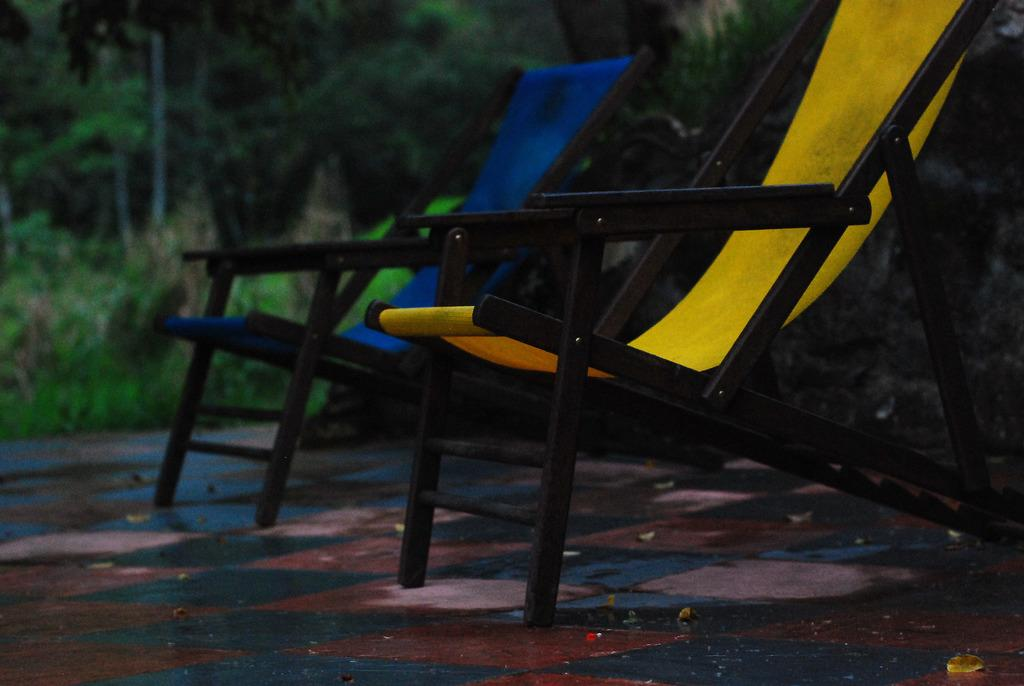How many chairs are in the image? There are two chairs in the image. Where are the chairs located? The chairs are placed on the ground. What can be seen in the background of the image? There are trees visible in the background of the image. What type of story is being told by the metal horn in the image? There is no metal horn present in the image, so no story is being told. 